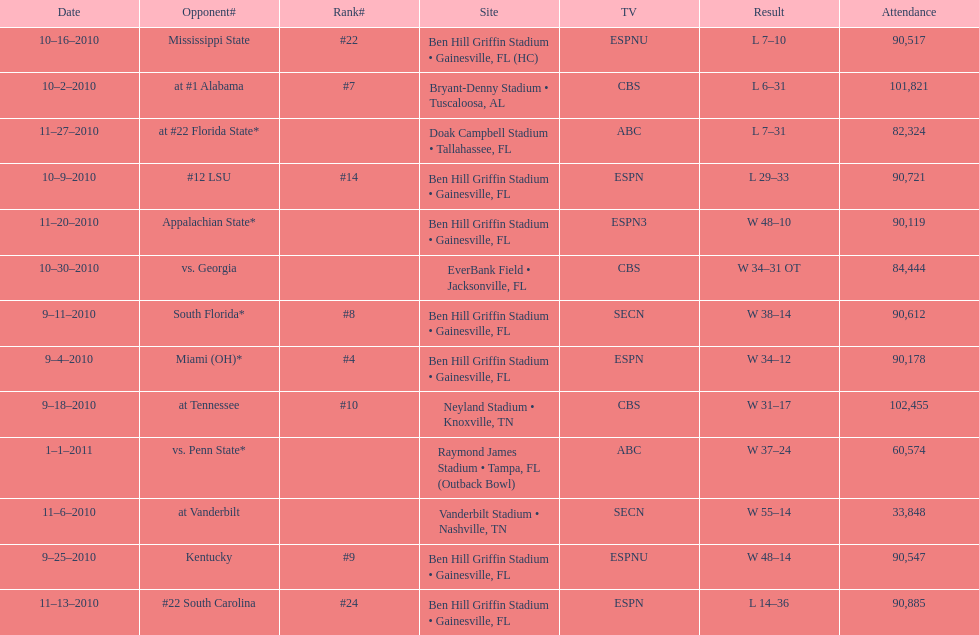How many games were played at the ben hill griffin stadium during the 2010-2011 season? 7. 